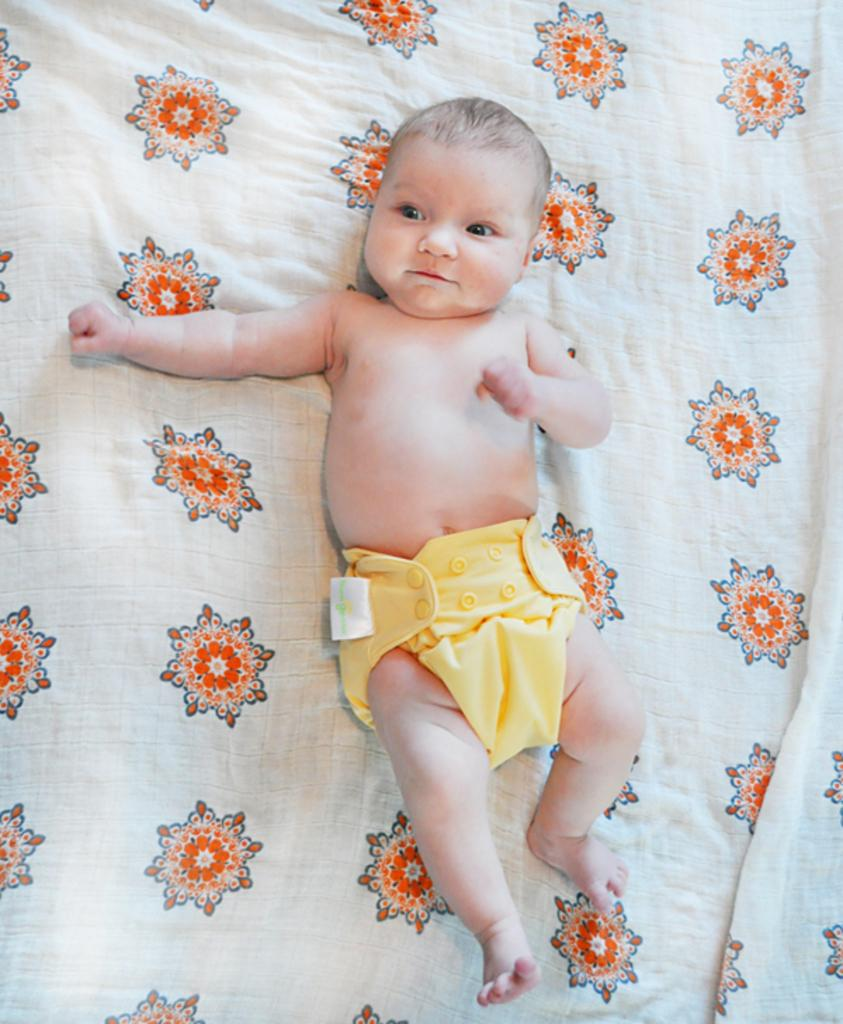What is the main subject of the image? There is a baby in the image. Where is the baby located? The baby is laying on a bed. What type of square-shaped tent can be seen in the image? There is no square-shaped tent present in the image; it features a baby laying on a bed. 